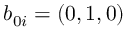<formula> <loc_0><loc_0><loc_500><loc_500>b _ { 0 i } = ( 0 , 1 , 0 )</formula> 